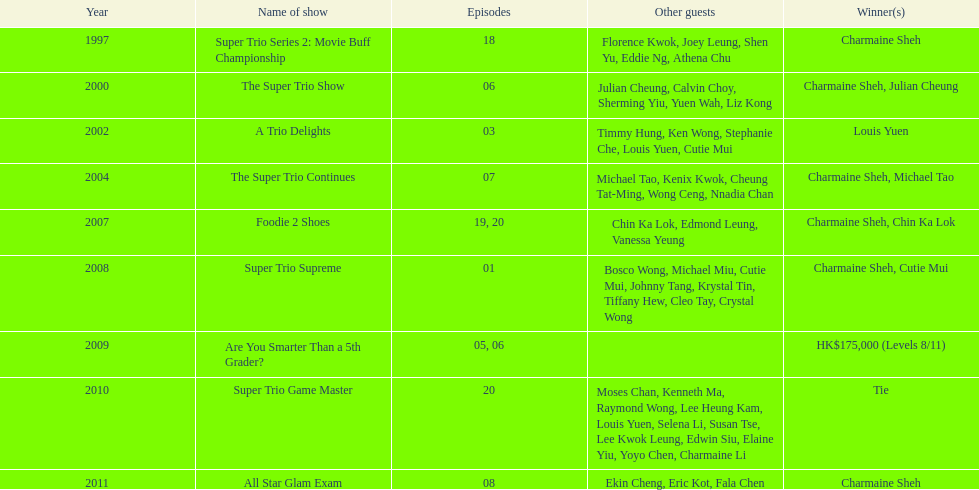What is the number of episodes charmaine sheh appeared in the variety show super trio 2: movie buff champions? 18. 